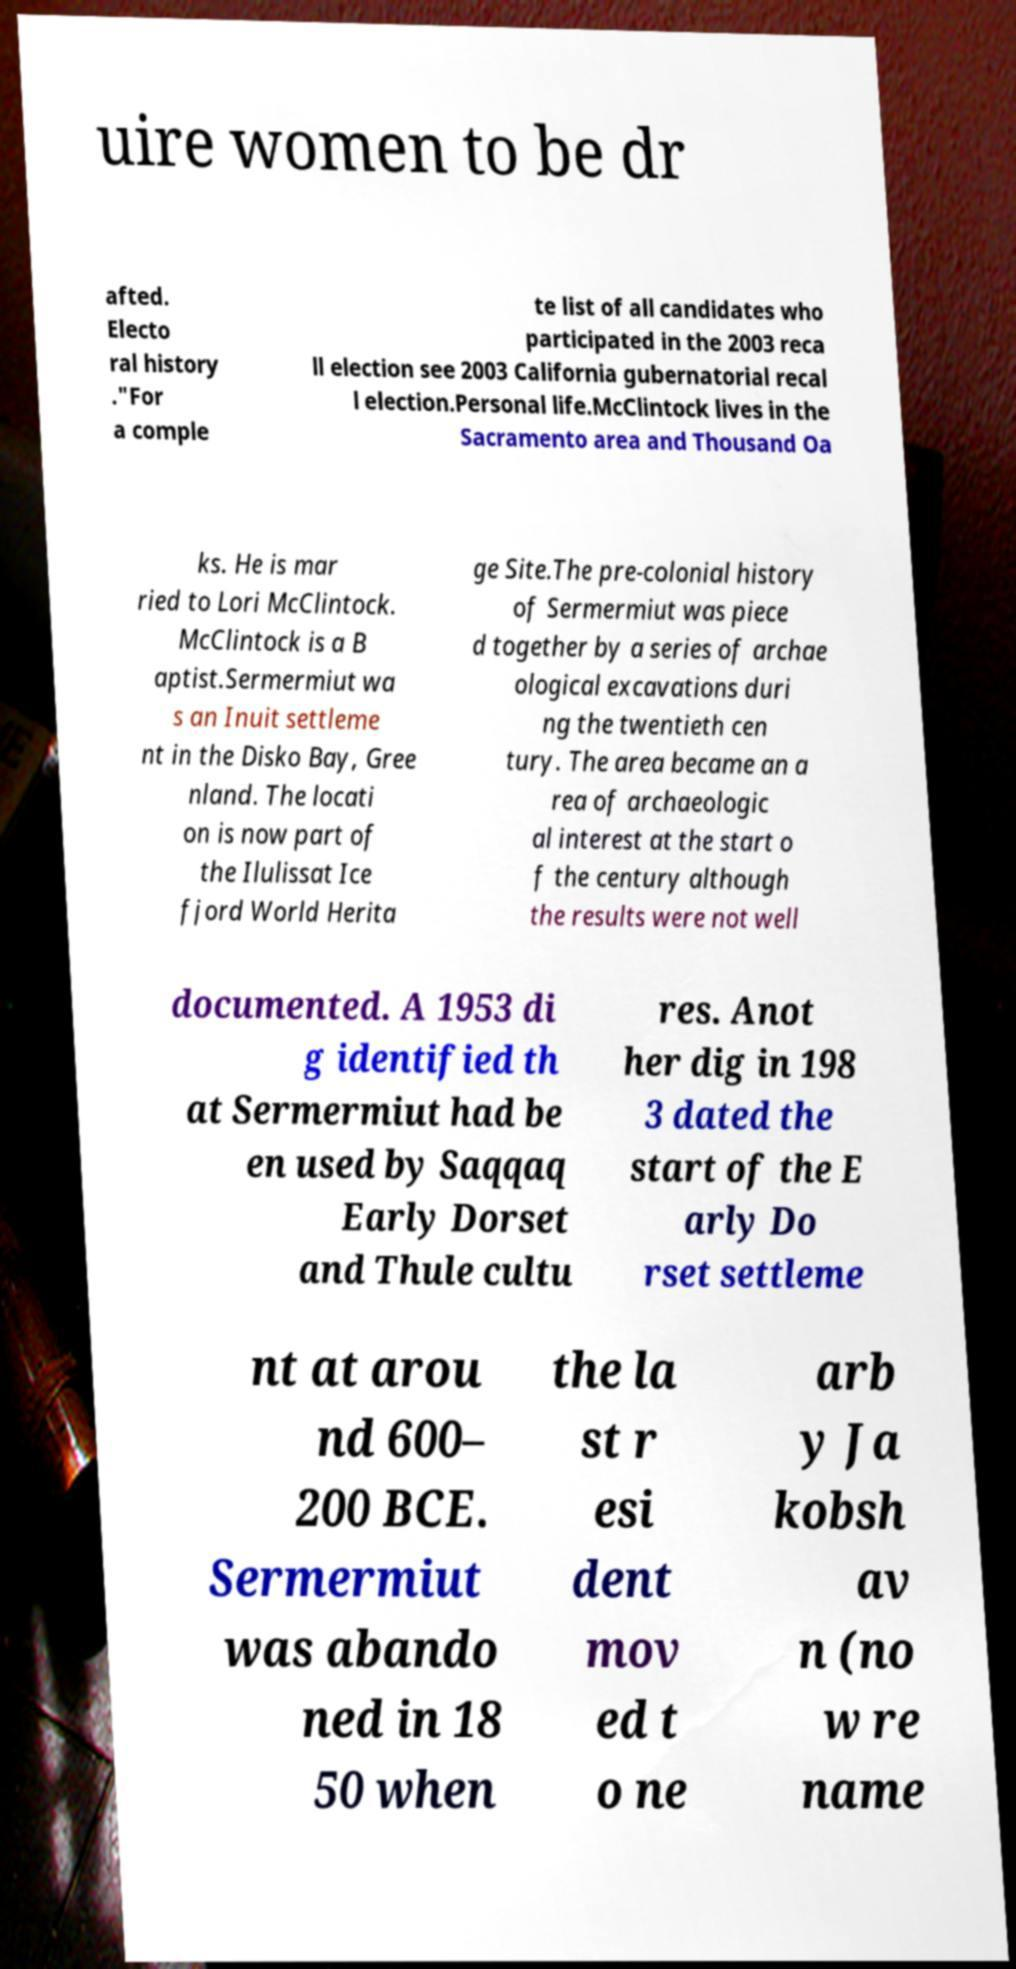Can you read and provide the text displayed in the image?This photo seems to have some interesting text. Can you extract and type it out for me? uire women to be dr afted. Electo ral history ."For a comple te list of all candidates who participated in the 2003 reca ll election see 2003 California gubernatorial recal l election.Personal life.McClintock lives in the Sacramento area and Thousand Oa ks. He is mar ried to Lori McClintock. McClintock is a B aptist.Sermermiut wa s an Inuit settleme nt in the Disko Bay, Gree nland. The locati on is now part of the Ilulissat Ice fjord World Herita ge Site.The pre-colonial history of Sermermiut was piece d together by a series of archae ological excavations duri ng the twentieth cen tury. The area became an a rea of archaeologic al interest at the start o f the century although the results were not well documented. A 1953 di g identified th at Sermermiut had be en used by Saqqaq Early Dorset and Thule cultu res. Anot her dig in 198 3 dated the start of the E arly Do rset settleme nt at arou nd 600– 200 BCE. Sermermiut was abando ned in 18 50 when the la st r esi dent mov ed t o ne arb y Ja kobsh av n (no w re name 